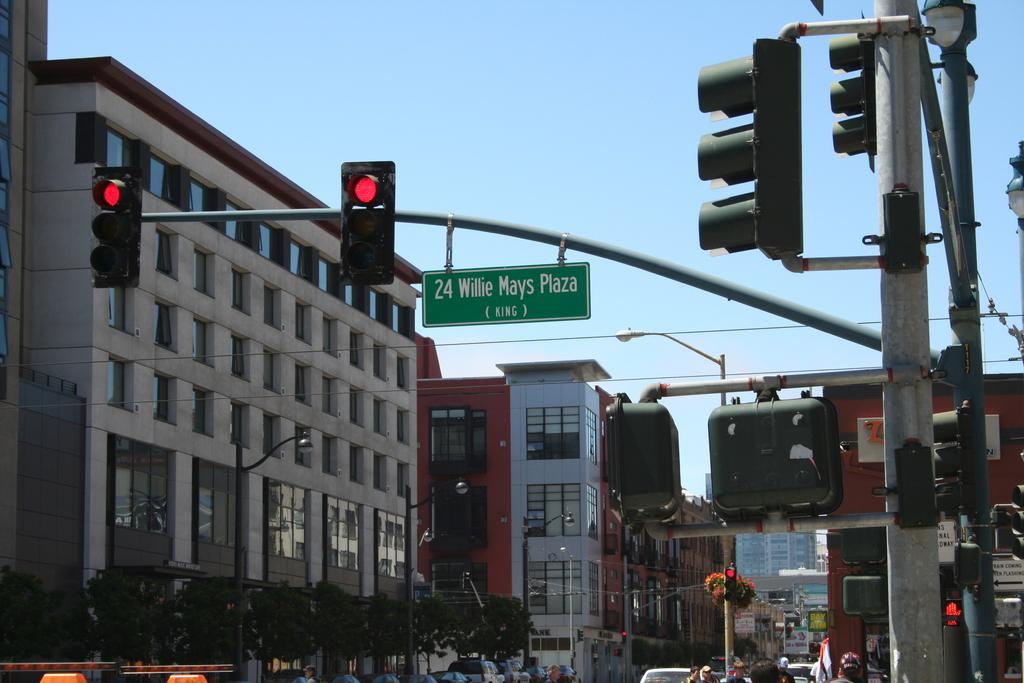<image>
Provide a brief description of the given image. A red traffic light with a street sign showing 24 Willie Mays Plaza. 